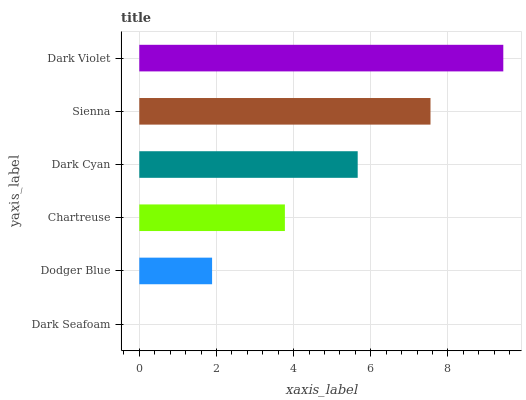Is Dark Seafoam the minimum?
Answer yes or no. Yes. Is Dark Violet the maximum?
Answer yes or no. Yes. Is Dodger Blue the minimum?
Answer yes or no. No. Is Dodger Blue the maximum?
Answer yes or no. No. Is Dodger Blue greater than Dark Seafoam?
Answer yes or no. Yes. Is Dark Seafoam less than Dodger Blue?
Answer yes or no. Yes. Is Dark Seafoam greater than Dodger Blue?
Answer yes or no. No. Is Dodger Blue less than Dark Seafoam?
Answer yes or no. No. Is Dark Cyan the high median?
Answer yes or no. Yes. Is Chartreuse the low median?
Answer yes or no. Yes. Is Sienna the high median?
Answer yes or no. No. Is Dodger Blue the low median?
Answer yes or no. No. 